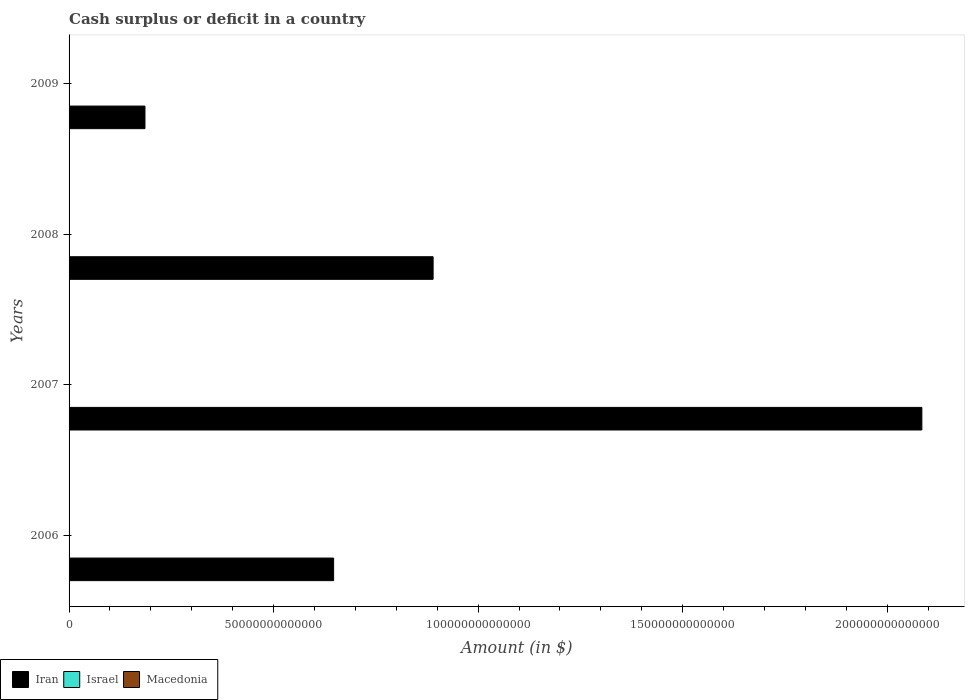How many bars are there on the 1st tick from the top?
Give a very brief answer. 1. How many bars are there on the 2nd tick from the bottom?
Your answer should be very brief. 2. What is the amount of cash surplus or deficit in Israel in 2007?
Your answer should be compact. 0. Across all years, what is the maximum amount of cash surplus or deficit in Macedonia?
Offer a very short reply. 9.41e+08. Across all years, what is the minimum amount of cash surplus or deficit in Israel?
Offer a very short reply. 0. In which year was the amount of cash surplus or deficit in Iran maximum?
Offer a very short reply. 2007. What is the difference between the amount of cash surplus or deficit in Iran in 2007 and that in 2009?
Provide a short and direct response. 1.90e+14. What is the difference between the amount of cash surplus or deficit in Iran in 2008 and the amount of cash surplus or deficit in Macedonia in 2007?
Give a very brief answer. 8.90e+13. What is the average amount of cash surplus or deficit in Iran per year?
Keep it short and to the point. 9.52e+13. What is the ratio of the amount of cash surplus or deficit in Iran in 2006 to that in 2008?
Your response must be concise. 0.73. What is the difference between the highest and the second highest amount of cash surplus or deficit in Iran?
Your response must be concise. 1.19e+14. What is the difference between the highest and the lowest amount of cash surplus or deficit in Macedonia?
Give a very brief answer. 9.41e+08. Is it the case that in every year, the sum of the amount of cash surplus or deficit in Israel and amount of cash surplus or deficit in Iran is greater than the amount of cash surplus or deficit in Macedonia?
Ensure brevity in your answer.  Yes. How many bars are there?
Provide a succinct answer. 5. Are all the bars in the graph horizontal?
Make the answer very short. Yes. How many years are there in the graph?
Provide a short and direct response. 4. What is the difference between two consecutive major ticks on the X-axis?
Offer a terse response. 5.00e+13. Are the values on the major ticks of X-axis written in scientific E-notation?
Offer a terse response. No. Does the graph contain any zero values?
Provide a succinct answer. Yes. Where does the legend appear in the graph?
Your answer should be compact. Bottom left. How are the legend labels stacked?
Offer a very short reply. Horizontal. What is the title of the graph?
Your answer should be very brief. Cash surplus or deficit in a country. Does "Micronesia" appear as one of the legend labels in the graph?
Offer a very short reply. No. What is the label or title of the X-axis?
Provide a short and direct response. Amount (in $). What is the Amount (in $) in Iran in 2006?
Offer a very short reply. 6.47e+13. What is the Amount (in $) in Israel in 2006?
Offer a terse response. 0. What is the Amount (in $) of Macedonia in 2006?
Your answer should be very brief. 0. What is the Amount (in $) in Iran in 2007?
Ensure brevity in your answer.  2.08e+14. What is the Amount (in $) in Israel in 2007?
Your answer should be compact. 0. What is the Amount (in $) of Macedonia in 2007?
Keep it short and to the point. 9.41e+08. What is the Amount (in $) in Iran in 2008?
Keep it short and to the point. 8.90e+13. What is the Amount (in $) in Israel in 2008?
Your response must be concise. 0. What is the Amount (in $) in Macedonia in 2008?
Offer a very short reply. 0. What is the Amount (in $) of Iran in 2009?
Offer a very short reply. 1.86e+13. What is the Amount (in $) of Israel in 2009?
Offer a very short reply. 0. Across all years, what is the maximum Amount (in $) of Iran?
Ensure brevity in your answer.  2.08e+14. Across all years, what is the maximum Amount (in $) in Macedonia?
Make the answer very short. 9.41e+08. Across all years, what is the minimum Amount (in $) of Iran?
Provide a short and direct response. 1.86e+13. What is the total Amount (in $) in Iran in the graph?
Offer a terse response. 3.81e+14. What is the total Amount (in $) of Macedonia in the graph?
Your response must be concise. 9.41e+08. What is the difference between the Amount (in $) of Iran in 2006 and that in 2007?
Offer a very short reply. -1.44e+14. What is the difference between the Amount (in $) in Iran in 2006 and that in 2008?
Give a very brief answer. -2.43e+13. What is the difference between the Amount (in $) in Iran in 2006 and that in 2009?
Your answer should be compact. 4.61e+13. What is the difference between the Amount (in $) in Iran in 2007 and that in 2008?
Provide a succinct answer. 1.19e+14. What is the difference between the Amount (in $) in Iran in 2007 and that in 2009?
Keep it short and to the point. 1.90e+14. What is the difference between the Amount (in $) of Iran in 2008 and that in 2009?
Offer a terse response. 7.04e+13. What is the difference between the Amount (in $) in Iran in 2006 and the Amount (in $) in Macedonia in 2007?
Offer a very short reply. 6.47e+13. What is the average Amount (in $) in Iran per year?
Offer a terse response. 9.52e+13. What is the average Amount (in $) in Macedonia per year?
Offer a very short reply. 2.35e+08. In the year 2007, what is the difference between the Amount (in $) in Iran and Amount (in $) in Macedonia?
Provide a succinct answer. 2.08e+14. What is the ratio of the Amount (in $) of Iran in 2006 to that in 2007?
Make the answer very short. 0.31. What is the ratio of the Amount (in $) of Iran in 2006 to that in 2008?
Offer a very short reply. 0.73. What is the ratio of the Amount (in $) of Iran in 2006 to that in 2009?
Provide a short and direct response. 3.49. What is the ratio of the Amount (in $) of Iran in 2007 to that in 2008?
Ensure brevity in your answer.  2.34. What is the ratio of the Amount (in $) in Iran in 2007 to that in 2009?
Provide a succinct answer. 11.24. What is the ratio of the Amount (in $) of Iran in 2008 to that in 2009?
Provide a succinct answer. 4.8. What is the difference between the highest and the second highest Amount (in $) in Iran?
Offer a terse response. 1.19e+14. What is the difference between the highest and the lowest Amount (in $) in Iran?
Provide a short and direct response. 1.90e+14. What is the difference between the highest and the lowest Amount (in $) in Macedonia?
Offer a very short reply. 9.41e+08. 